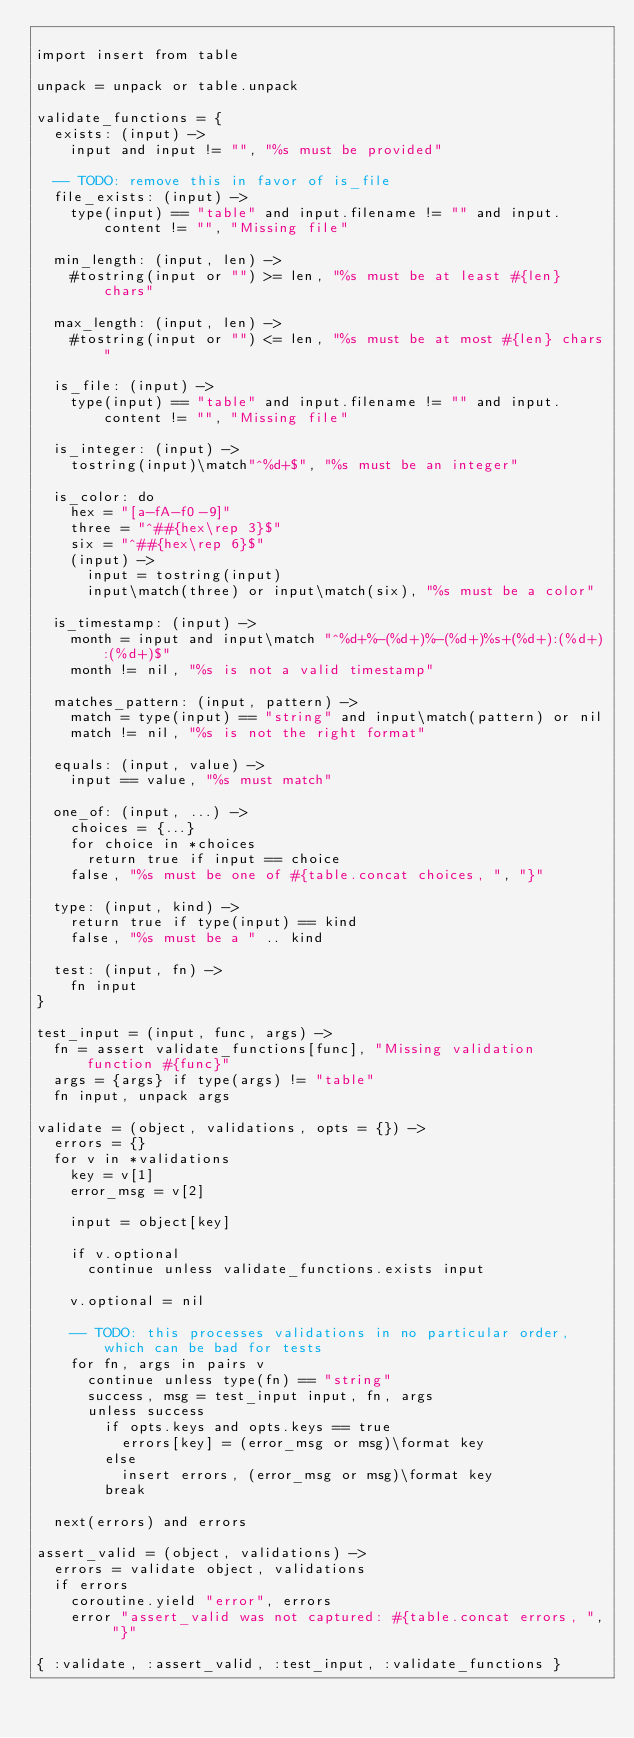Convert code to text. <code><loc_0><loc_0><loc_500><loc_500><_MoonScript_>
import insert from table

unpack = unpack or table.unpack

validate_functions = {
  exists: (input) ->
    input and input != "", "%s must be provided"

  -- TODO: remove this in favor of is_file
  file_exists: (input) ->
    type(input) == "table" and input.filename != "" and input.content != "", "Missing file"

  min_length: (input, len) ->
    #tostring(input or "") >= len, "%s must be at least #{len} chars"

  max_length: (input, len) ->
    #tostring(input or "") <= len, "%s must be at most #{len} chars"

  is_file: (input) ->
    type(input) == "table" and input.filename != "" and input.content != "", "Missing file"

  is_integer: (input) ->
    tostring(input)\match"^%d+$", "%s must be an integer"

  is_color: do
    hex = "[a-fA-f0-9]"
    three = "^##{hex\rep 3}$"
    six = "^##{hex\rep 6}$"
    (input) ->
      input = tostring(input)
      input\match(three) or input\match(six), "%s must be a color"

  is_timestamp: (input) ->
    month = input and input\match "^%d+%-(%d+)%-(%d+)%s+(%d+):(%d+):(%d+)$"
    month != nil, "%s is not a valid timestamp"

  matches_pattern: (input, pattern) ->
    match = type(input) == "string" and input\match(pattern) or nil
    match != nil, "%s is not the right format"

  equals: (input, value) ->
    input == value, "%s must match"

  one_of: (input, ...) ->
    choices = {...}
    for choice in *choices
      return true if input == choice
    false, "%s must be one of #{table.concat choices, ", "}"

  type: (input, kind) ->
    return true if type(input) == kind
    false, "%s must be a " .. kind

  test: (input, fn) ->
    fn input
}

test_input = (input, func, args) ->
  fn = assert validate_functions[func], "Missing validation function #{func}"
  args = {args} if type(args) != "table"
  fn input, unpack args

validate = (object, validations, opts = {}) ->
  errors = {}
  for v in *validations
    key = v[1]
    error_msg = v[2]

    input = object[key]

    if v.optional
      continue unless validate_functions.exists input

    v.optional = nil

    -- TODO: this processes validations in no particular order, which can be bad for tests
    for fn, args in pairs v
      continue unless type(fn) == "string"
      success, msg = test_input input, fn, args
      unless success
        if opts.keys and opts.keys == true
          errors[key] = (error_msg or msg)\format key
        else
          insert errors, (error_msg or msg)\format key
        break

  next(errors) and errors

assert_valid = (object, validations) ->
  errors = validate object, validations
  if errors
    coroutine.yield "error", errors
    error "assert_valid was not captured: #{table.concat errors, ", "}"

{ :validate, :assert_valid, :test_input, :validate_functions }
</code> 